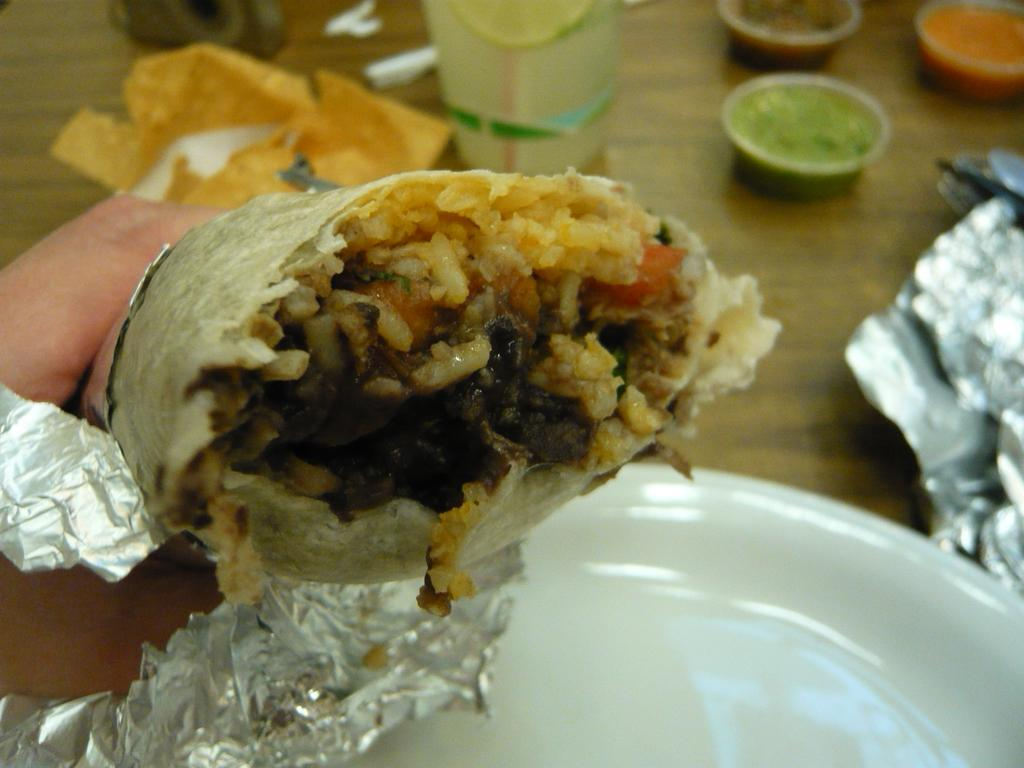What type of food is shown in the image? There is a chicken wrap in the image. What color is the plate that the food is on? There is a white plate in the image. What is used to cover the food? There is aluminum foil in the image. What types of sauce are present in the image? There is green sauce and red sauce in the image. Where are all the items placed? All items are placed on a table top. How many beetles can be seen crawling on the table in the image? There are no beetles present in the image; it only shows a chicken wrap, a white plate, aluminum foil, green sauce, red sauce, and a table top. 